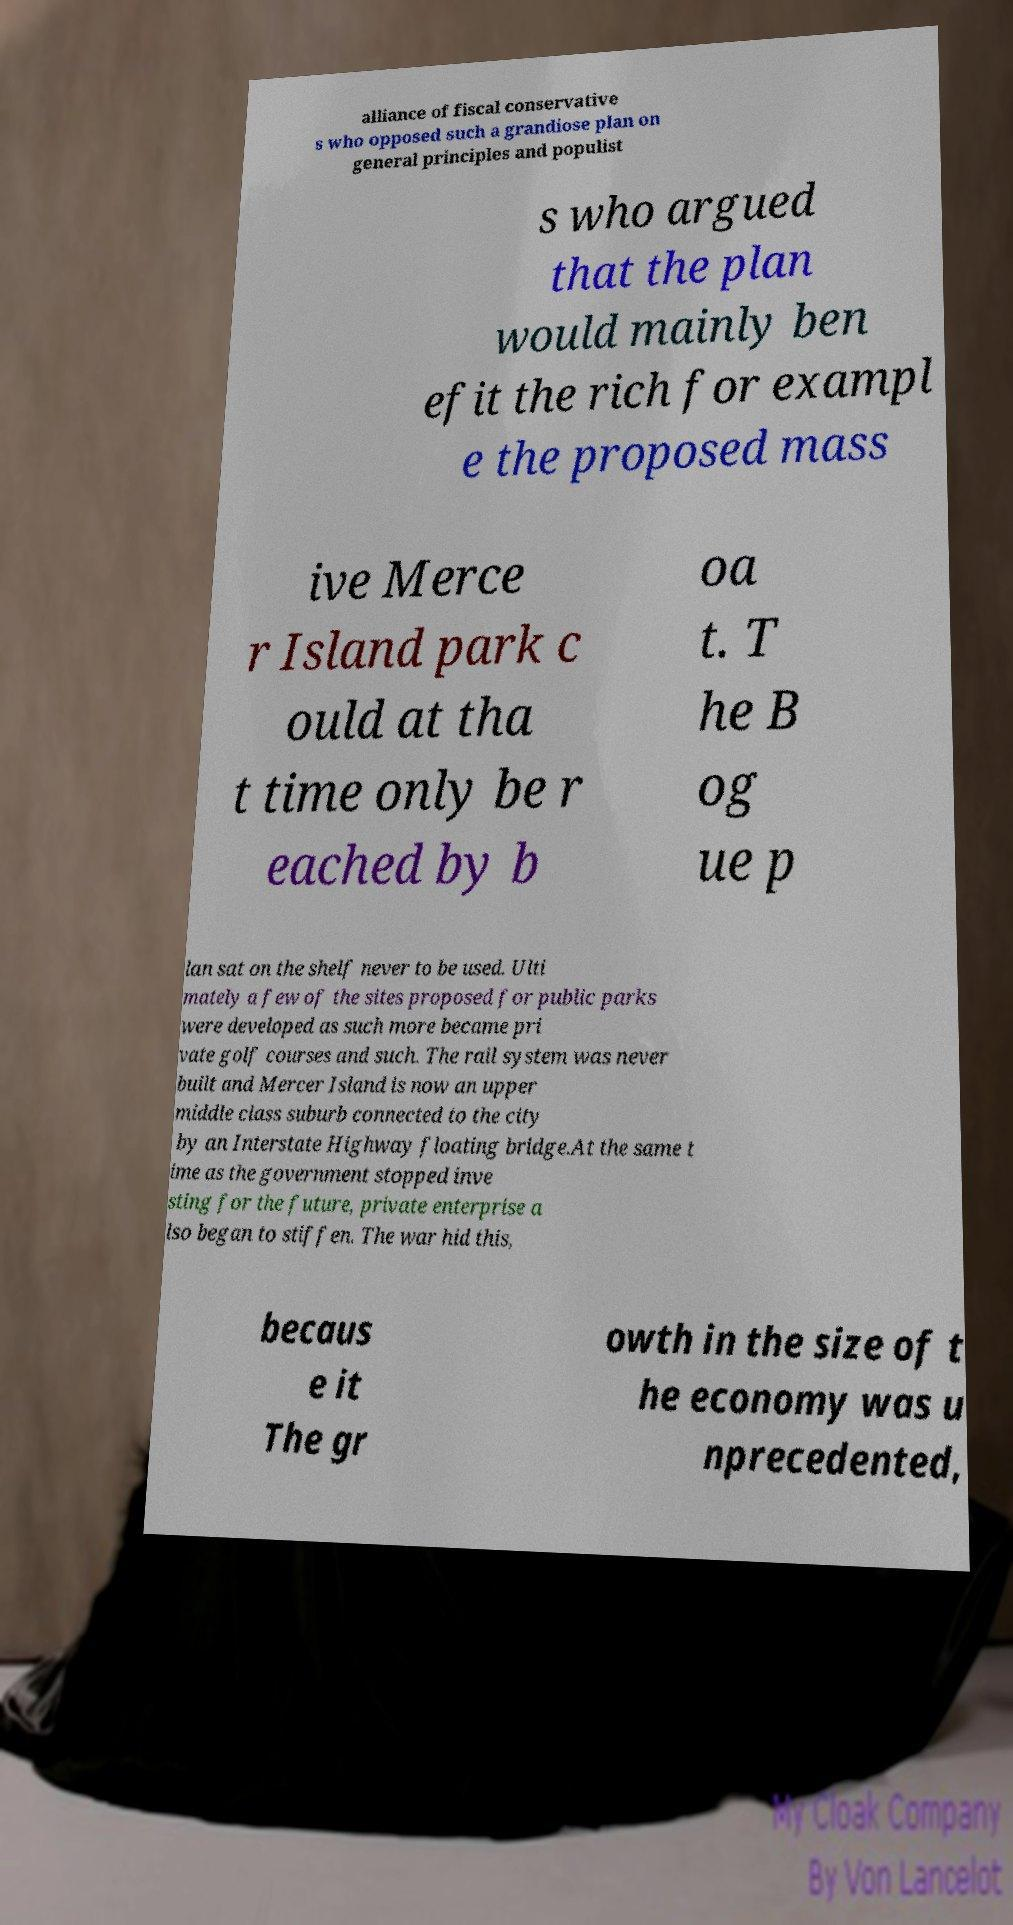For documentation purposes, I need the text within this image transcribed. Could you provide that? alliance of fiscal conservative s who opposed such a grandiose plan on general principles and populist s who argued that the plan would mainly ben efit the rich for exampl e the proposed mass ive Merce r Island park c ould at tha t time only be r eached by b oa t. T he B og ue p lan sat on the shelf never to be used. Ulti mately a few of the sites proposed for public parks were developed as such more became pri vate golf courses and such. The rail system was never built and Mercer Island is now an upper middle class suburb connected to the city by an Interstate Highway floating bridge.At the same t ime as the government stopped inve sting for the future, private enterprise a lso began to stiffen. The war hid this, becaus e it The gr owth in the size of t he economy was u nprecedented, 